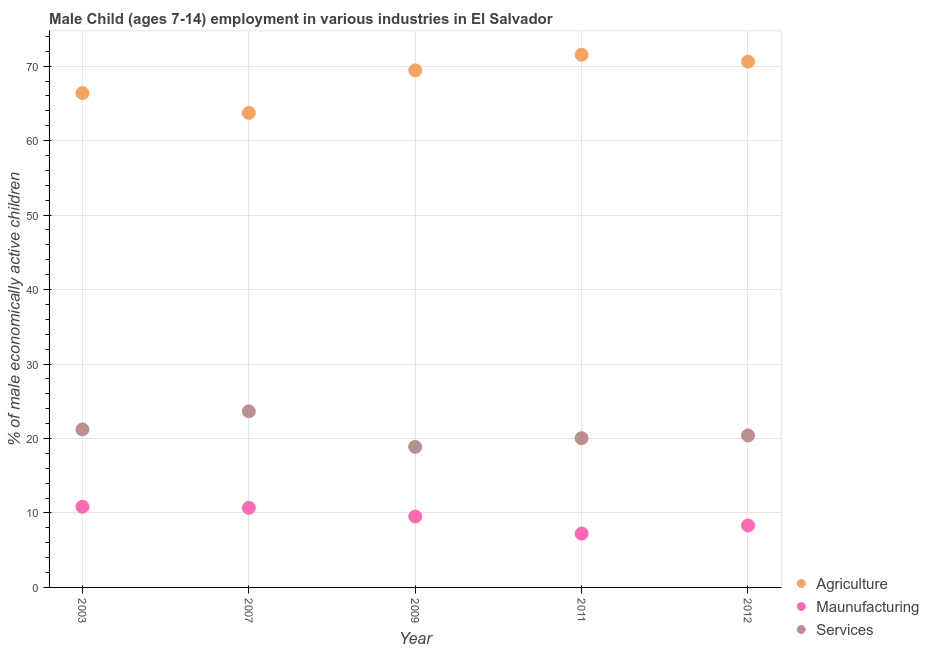Is the number of dotlines equal to the number of legend labels?
Ensure brevity in your answer.  Yes. What is the percentage of economically active children in manufacturing in 2012?
Your answer should be compact. 8.32. Across all years, what is the maximum percentage of economically active children in agriculture?
Give a very brief answer. 71.53. Across all years, what is the minimum percentage of economically active children in services?
Give a very brief answer. 18.87. What is the total percentage of economically active children in manufacturing in the graph?
Give a very brief answer. 46.59. What is the difference between the percentage of economically active children in agriculture in 2003 and that in 2007?
Your answer should be very brief. 2.66. What is the difference between the percentage of economically active children in services in 2003 and the percentage of economically active children in agriculture in 2012?
Ensure brevity in your answer.  -49.39. What is the average percentage of economically active children in agriculture per year?
Ensure brevity in your answer.  68.33. In the year 2011, what is the difference between the percentage of economically active children in manufacturing and percentage of economically active children in services?
Make the answer very short. -12.81. In how many years, is the percentage of economically active children in agriculture greater than 64 %?
Make the answer very short. 4. What is the ratio of the percentage of economically active children in manufacturing in 2003 to that in 2012?
Your answer should be very brief. 1.3. Is the difference between the percentage of economically active children in agriculture in 2003 and 2012 greater than the difference between the percentage of economically active children in manufacturing in 2003 and 2012?
Your answer should be compact. No. What is the difference between the highest and the second highest percentage of economically active children in agriculture?
Your response must be concise. 0.92. What is the difference between the highest and the lowest percentage of economically active children in agriculture?
Your answer should be compact. 7.81. In how many years, is the percentage of economically active children in manufacturing greater than the average percentage of economically active children in manufacturing taken over all years?
Your answer should be very brief. 3. Is it the case that in every year, the sum of the percentage of economically active children in agriculture and percentage of economically active children in manufacturing is greater than the percentage of economically active children in services?
Ensure brevity in your answer.  Yes. Does the percentage of economically active children in services monotonically increase over the years?
Your response must be concise. No. How many dotlines are there?
Your response must be concise. 3. How many years are there in the graph?
Provide a short and direct response. 5. What is the difference between two consecutive major ticks on the Y-axis?
Keep it short and to the point. 10. Does the graph contain any zero values?
Give a very brief answer. No. How are the legend labels stacked?
Provide a succinct answer. Vertical. What is the title of the graph?
Your response must be concise. Male Child (ages 7-14) employment in various industries in El Salvador. What is the label or title of the X-axis?
Make the answer very short. Year. What is the label or title of the Y-axis?
Make the answer very short. % of male economically active children. What is the % of male economically active children in Agriculture in 2003?
Ensure brevity in your answer.  66.38. What is the % of male economically active children of Maunufacturing in 2003?
Ensure brevity in your answer.  10.83. What is the % of male economically active children of Services in 2003?
Give a very brief answer. 21.22. What is the % of male economically active children in Agriculture in 2007?
Your response must be concise. 63.72. What is the % of male economically active children of Maunufacturing in 2007?
Offer a very short reply. 10.69. What is the % of male economically active children in Services in 2007?
Make the answer very short. 23.65. What is the % of male economically active children of Agriculture in 2009?
Provide a short and direct response. 69.43. What is the % of male economically active children of Maunufacturing in 2009?
Your answer should be compact. 9.52. What is the % of male economically active children in Services in 2009?
Provide a succinct answer. 18.87. What is the % of male economically active children of Agriculture in 2011?
Your response must be concise. 71.53. What is the % of male economically active children of Maunufacturing in 2011?
Ensure brevity in your answer.  7.23. What is the % of male economically active children of Services in 2011?
Provide a short and direct response. 20.04. What is the % of male economically active children in Agriculture in 2012?
Your answer should be very brief. 70.61. What is the % of male economically active children in Maunufacturing in 2012?
Your response must be concise. 8.32. What is the % of male economically active children of Services in 2012?
Provide a short and direct response. 20.41. Across all years, what is the maximum % of male economically active children of Agriculture?
Your answer should be very brief. 71.53. Across all years, what is the maximum % of male economically active children of Maunufacturing?
Provide a succinct answer. 10.83. Across all years, what is the maximum % of male economically active children of Services?
Give a very brief answer. 23.65. Across all years, what is the minimum % of male economically active children of Agriculture?
Provide a succinct answer. 63.72. Across all years, what is the minimum % of male economically active children of Maunufacturing?
Your response must be concise. 7.23. Across all years, what is the minimum % of male economically active children of Services?
Offer a very short reply. 18.87. What is the total % of male economically active children in Agriculture in the graph?
Make the answer very short. 341.67. What is the total % of male economically active children of Maunufacturing in the graph?
Ensure brevity in your answer.  46.59. What is the total % of male economically active children in Services in the graph?
Provide a succinct answer. 104.19. What is the difference between the % of male economically active children in Agriculture in 2003 and that in 2007?
Offer a terse response. 2.66. What is the difference between the % of male economically active children of Maunufacturing in 2003 and that in 2007?
Give a very brief answer. 0.14. What is the difference between the % of male economically active children of Services in 2003 and that in 2007?
Your response must be concise. -2.43. What is the difference between the % of male economically active children in Agriculture in 2003 and that in 2009?
Your answer should be compact. -3.05. What is the difference between the % of male economically active children of Maunufacturing in 2003 and that in 2009?
Keep it short and to the point. 1.31. What is the difference between the % of male economically active children in Services in 2003 and that in 2009?
Offer a terse response. 2.35. What is the difference between the % of male economically active children of Agriculture in 2003 and that in 2011?
Your answer should be compact. -5.15. What is the difference between the % of male economically active children of Maunufacturing in 2003 and that in 2011?
Your response must be concise. 3.6. What is the difference between the % of male economically active children in Services in 2003 and that in 2011?
Offer a terse response. 1.18. What is the difference between the % of male economically active children of Agriculture in 2003 and that in 2012?
Keep it short and to the point. -4.23. What is the difference between the % of male economically active children of Maunufacturing in 2003 and that in 2012?
Your answer should be very brief. 2.51. What is the difference between the % of male economically active children in Services in 2003 and that in 2012?
Your answer should be very brief. 0.81. What is the difference between the % of male economically active children of Agriculture in 2007 and that in 2009?
Offer a terse response. -5.71. What is the difference between the % of male economically active children of Maunufacturing in 2007 and that in 2009?
Make the answer very short. 1.17. What is the difference between the % of male economically active children of Services in 2007 and that in 2009?
Your answer should be compact. 4.78. What is the difference between the % of male economically active children of Agriculture in 2007 and that in 2011?
Your response must be concise. -7.81. What is the difference between the % of male economically active children in Maunufacturing in 2007 and that in 2011?
Your answer should be very brief. 3.46. What is the difference between the % of male economically active children in Services in 2007 and that in 2011?
Your answer should be compact. 3.61. What is the difference between the % of male economically active children of Agriculture in 2007 and that in 2012?
Offer a very short reply. -6.89. What is the difference between the % of male economically active children of Maunufacturing in 2007 and that in 2012?
Your response must be concise. 2.37. What is the difference between the % of male economically active children of Services in 2007 and that in 2012?
Your response must be concise. 3.24. What is the difference between the % of male economically active children of Agriculture in 2009 and that in 2011?
Your response must be concise. -2.1. What is the difference between the % of male economically active children in Maunufacturing in 2009 and that in 2011?
Give a very brief answer. 2.29. What is the difference between the % of male economically active children of Services in 2009 and that in 2011?
Offer a very short reply. -1.17. What is the difference between the % of male economically active children in Agriculture in 2009 and that in 2012?
Ensure brevity in your answer.  -1.18. What is the difference between the % of male economically active children of Services in 2009 and that in 2012?
Offer a terse response. -1.54. What is the difference between the % of male economically active children of Agriculture in 2011 and that in 2012?
Provide a short and direct response. 0.92. What is the difference between the % of male economically active children in Maunufacturing in 2011 and that in 2012?
Your answer should be compact. -1.09. What is the difference between the % of male economically active children in Services in 2011 and that in 2012?
Your answer should be compact. -0.37. What is the difference between the % of male economically active children of Agriculture in 2003 and the % of male economically active children of Maunufacturing in 2007?
Your answer should be very brief. 55.69. What is the difference between the % of male economically active children of Agriculture in 2003 and the % of male economically active children of Services in 2007?
Ensure brevity in your answer.  42.73. What is the difference between the % of male economically active children in Maunufacturing in 2003 and the % of male economically active children in Services in 2007?
Offer a terse response. -12.82. What is the difference between the % of male economically active children of Agriculture in 2003 and the % of male economically active children of Maunufacturing in 2009?
Offer a terse response. 56.86. What is the difference between the % of male economically active children of Agriculture in 2003 and the % of male economically active children of Services in 2009?
Your answer should be very brief. 47.51. What is the difference between the % of male economically active children in Maunufacturing in 2003 and the % of male economically active children in Services in 2009?
Provide a succinct answer. -8.04. What is the difference between the % of male economically active children of Agriculture in 2003 and the % of male economically active children of Maunufacturing in 2011?
Offer a terse response. 59.15. What is the difference between the % of male economically active children in Agriculture in 2003 and the % of male economically active children in Services in 2011?
Your response must be concise. 46.34. What is the difference between the % of male economically active children of Maunufacturing in 2003 and the % of male economically active children of Services in 2011?
Keep it short and to the point. -9.21. What is the difference between the % of male economically active children of Agriculture in 2003 and the % of male economically active children of Maunufacturing in 2012?
Keep it short and to the point. 58.06. What is the difference between the % of male economically active children of Agriculture in 2003 and the % of male economically active children of Services in 2012?
Provide a succinct answer. 45.97. What is the difference between the % of male economically active children of Maunufacturing in 2003 and the % of male economically active children of Services in 2012?
Your response must be concise. -9.58. What is the difference between the % of male economically active children in Agriculture in 2007 and the % of male economically active children in Maunufacturing in 2009?
Make the answer very short. 54.2. What is the difference between the % of male economically active children in Agriculture in 2007 and the % of male economically active children in Services in 2009?
Ensure brevity in your answer.  44.85. What is the difference between the % of male economically active children in Maunufacturing in 2007 and the % of male economically active children in Services in 2009?
Provide a succinct answer. -8.18. What is the difference between the % of male economically active children in Agriculture in 2007 and the % of male economically active children in Maunufacturing in 2011?
Give a very brief answer. 56.49. What is the difference between the % of male economically active children in Agriculture in 2007 and the % of male economically active children in Services in 2011?
Provide a short and direct response. 43.68. What is the difference between the % of male economically active children of Maunufacturing in 2007 and the % of male economically active children of Services in 2011?
Offer a very short reply. -9.35. What is the difference between the % of male economically active children in Agriculture in 2007 and the % of male economically active children in Maunufacturing in 2012?
Make the answer very short. 55.4. What is the difference between the % of male economically active children of Agriculture in 2007 and the % of male economically active children of Services in 2012?
Keep it short and to the point. 43.31. What is the difference between the % of male economically active children of Maunufacturing in 2007 and the % of male economically active children of Services in 2012?
Give a very brief answer. -9.72. What is the difference between the % of male economically active children in Agriculture in 2009 and the % of male economically active children in Maunufacturing in 2011?
Your answer should be compact. 62.2. What is the difference between the % of male economically active children in Agriculture in 2009 and the % of male economically active children in Services in 2011?
Provide a succinct answer. 49.39. What is the difference between the % of male economically active children of Maunufacturing in 2009 and the % of male economically active children of Services in 2011?
Your response must be concise. -10.52. What is the difference between the % of male economically active children in Agriculture in 2009 and the % of male economically active children in Maunufacturing in 2012?
Provide a short and direct response. 61.11. What is the difference between the % of male economically active children of Agriculture in 2009 and the % of male economically active children of Services in 2012?
Provide a succinct answer. 49.02. What is the difference between the % of male economically active children in Maunufacturing in 2009 and the % of male economically active children in Services in 2012?
Your answer should be compact. -10.89. What is the difference between the % of male economically active children in Agriculture in 2011 and the % of male economically active children in Maunufacturing in 2012?
Give a very brief answer. 63.21. What is the difference between the % of male economically active children of Agriculture in 2011 and the % of male economically active children of Services in 2012?
Offer a very short reply. 51.12. What is the difference between the % of male economically active children of Maunufacturing in 2011 and the % of male economically active children of Services in 2012?
Your answer should be very brief. -13.18. What is the average % of male economically active children of Agriculture per year?
Ensure brevity in your answer.  68.33. What is the average % of male economically active children of Maunufacturing per year?
Your answer should be compact. 9.32. What is the average % of male economically active children of Services per year?
Provide a short and direct response. 20.84. In the year 2003, what is the difference between the % of male economically active children of Agriculture and % of male economically active children of Maunufacturing?
Ensure brevity in your answer.  55.55. In the year 2003, what is the difference between the % of male economically active children of Agriculture and % of male economically active children of Services?
Your response must be concise. 45.16. In the year 2003, what is the difference between the % of male economically active children in Maunufacturing and % of male economically active children in Services?
Offer a terse response. -10.39. In the year 2007, what is the difference between the % of male economically active children of Agriculture and % of male economically active children of Maunufacturing?
Give a very brief answer. 53.03. In the year 2007, what is the difference between the % of male economically active children of Agriculture and % of male economically active children of Services?
Make the answer very short. 40.07. In the year 2007, what is the difference between the % of male economically active children in Maunufacturing and % of male economically active children in Services?
Your response must be concise. -12.96. In the year 2009, what is the difference between the % of male economically active children of Agriculture and % of male economically active children of Maunufacturing?
Provide a short and direct response. 59.91. In the year 2009, what is the difference between the % of male economically active children of Agriculture and % of male economically active children of Services?
Keep it short and to the point. 50.56. In the year 2009, what is the difference between the % of male economically active children of Maunufacturing and % of male economically active children of Services?
Offer a terse response. -9.35. In the year 2011, what is the difference between the % of male economically active children of Agriculture and % of male economically active children of Maunufacturing?
Keep it short and to the point. 64.3. In the year 2011, what is the difference between the % of male economically active children of Agriculture and % of male economically active children of Services?
Provide a succinct answer. 51.49. In the year 2011, what is the difference between the % of male economically active children of Maunufacturing and % of male economically active children of Services?
Your response must be concise. -12.81. In the year 2012, what is the difference between the % of male economically active children in Agriculture and % of male economically active children in Maunufacturing?
Provide a succinct answer. 62.29. In the year 2012, what is the difference between the % of male economically active children of Agriculture and % of male economically active children of Services?
Give a very brief answer. 50.2. In the year 2012, what is the difference between the % of male economically active children in Maunufacturing and % of male economically active children in Services?
Offer a very short reply. -12.09. What is the ratio of the % of male economically active children in Agriculture in 2003 to that in 2007?
Your response must be concise. 1.04. What is the ratio of the % of male economically active children in Services in 2003 to that in 2007?
Provide a succinct answer. 0.9. What is the ratio of the % of male economically active children in Agriculture in 2003 to that in 2009?
Your answer should be compact. 0.96. What is the ratio of the % of male economically active children of Maunufacturing in 2003 to that in 2009?
Your response must be concise. 1.14. What is the ratio of the % of male economically active children of Services in 2003 to that in 2009?
Your answer should be very brief. 1.12. What is the ratio of the % of male economically active children in Agriculture in 2003 to that in 2011?
Keep it short and to the point. 0.93. What is the ratio of the % of male economically active children of Maunufacturing in 2003 to that in 2011?
Provide a succinct answer. 1.5. What is the ratio of the % of male economically active children of Services in 2003 to that in 2011?
Provide a succinct answer. 1.06. What is the ratio of the % of male economically active children of Agriculture in 2003 to that in 2012?
Offer a terse response. 0.94. What is the ratio of the % of male economically active children of Maunufacturing in 2003 to that in 2012?
Your answer should be very brief. 1.3. What is the ratio of the % of male economically active children of Services in 2003 to that in 2012?
Offer a terse response. 1.04. What is the ratio of the % of male economically active children of Agriculture in 2007 to that in 2009?
Your answer should be compact. 0.92. What is the ratio of the % of male economically active children in Maunufacturing in 2007 to that in 2009?
Ensure brevity in your answer.  1.12. What is the ratio of the % of male economically active children of Services in 2007 to that in 2009?
Keep it short and to the point. 1.25. What is the ratio of the % of male economically active children of Agriculture in 2007 to that in 2011?
Offer a very short reply. 0.89. What is the ratio of the % of male economically active children in Maunufacturing in 2007 to that in 2011?
Provide a short and direct response. 1.48. What is the ratio of the % of male economically active children in Services in 2007 to that in 2011?
Your answer should be very brief. 1.18. What is the ratio of the % of male economically active children in Agriculture in 2007 to that in 2012?
Keep it short and to the point. 0.9. What is the ratio of the % of male economically active children in Maunufacturing in 2007 to that in 2012?
Your answer should be very brief. 1.28. What is the ratio of the % of male economically active children in Services in 2007 to that in 2012?
Your answer should be very brief. 1.16. What is the ratio of the % of male economically active children of Agriculture in 2009 to that in 2011?
Your answer should be very brief. 0.97. What is the ratio of the % of male economically active children in Maunufacturing in 2009 to that in 2011?
Offer a terse response. 1.32. What is the ratio of the % of male economically active children in Services in 2009 to that in 2011?
Ensure brevity in your answer.  0.94. What is the ratio of the % of male economically active children of Agriculture in 2009 to that in 2012?
Make the answer very short. 0.98. What is the ratio of the % of male economically active children in Maunufacturing in 2009 to that in 2012?
Provide a succinct answer. 1.14. What is the ratio of the % of male economically active children in Services in 2009 to that in 2012?
Provide a short and direct response. 0.92. What is the ratio of the % of male economically active children of Maunufacturing in 2011 to that in 2012?
Offer a terse response. 0.87. What is the ratio of the % of male economically active children of Services in 2011 to that in 2012?
Your answer should be very brief. 0.98. What is the difference between the highest and the second highest % of male economically active children of Maunufacturing?
Provide a succinct answer. 0.14. What is the difference between the highest and the second highest % of male economically active children of Services?
Your response must be concise. 2.43. What is the difference between the highest and the lowest % of male economically active children of Agriculture?
Keep it short and to the point. 7.81. What is the difference between the highest and the lowest % of male economically active children in Maunufacturing?
Keep it short and to the point. 3.6. What is the difference between the highest and the lowest % of male economically active children of Services?
Give a very brief answer. 4.78. 